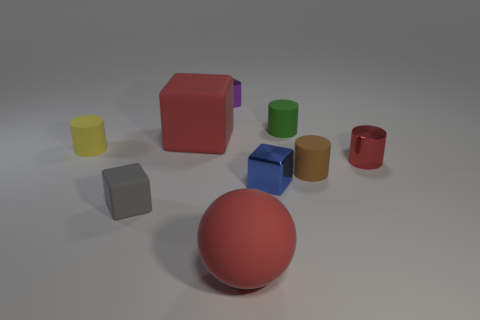Subtract all red cylinders. Subtract all gray cubes. How many cylinders are left? 3 Add 1 purple objects. How many objects exist? 10 Subtract all cylinders. How many objects are left? 5 Subtract all green rubber cylinders. Subtract all tiny green things. How many objects are left? 7 Add 9 large matte blocks. How many large matte blocks are left? 10 Add 1 red cylinders. How many red cylinders exist? 2 Subtract 0 gray spheres. How many objects are left? 9 